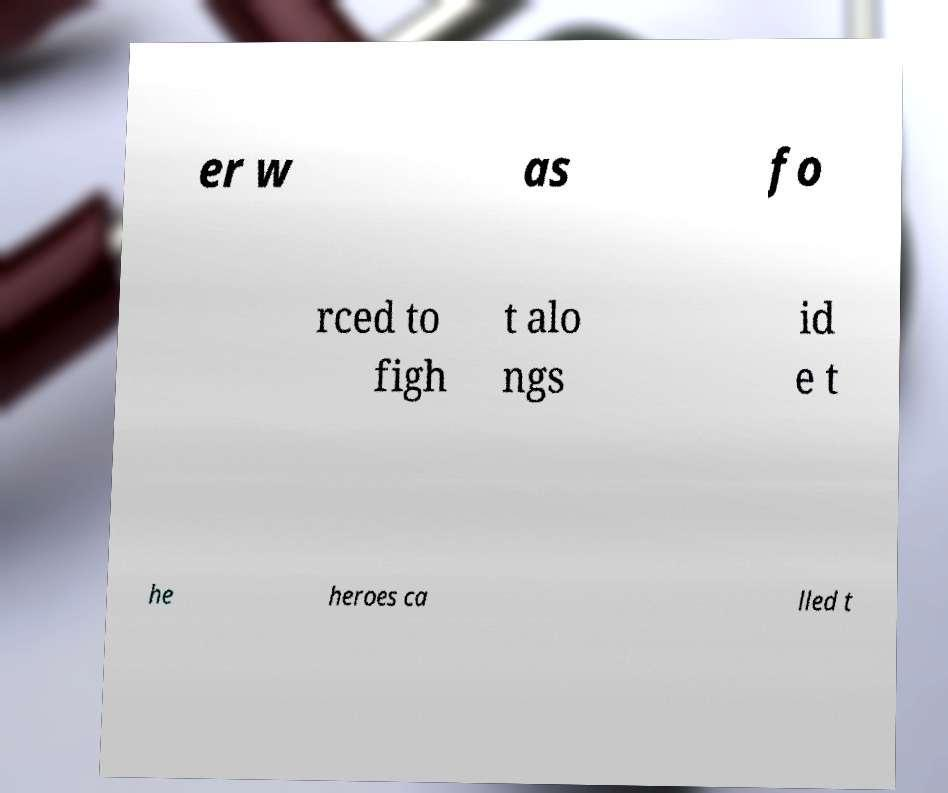For documentation purposes, I need the text within this image transcribed. Could you provide that? er w as fo rced to figh t alo ngs id e t he heroes ca lled t 